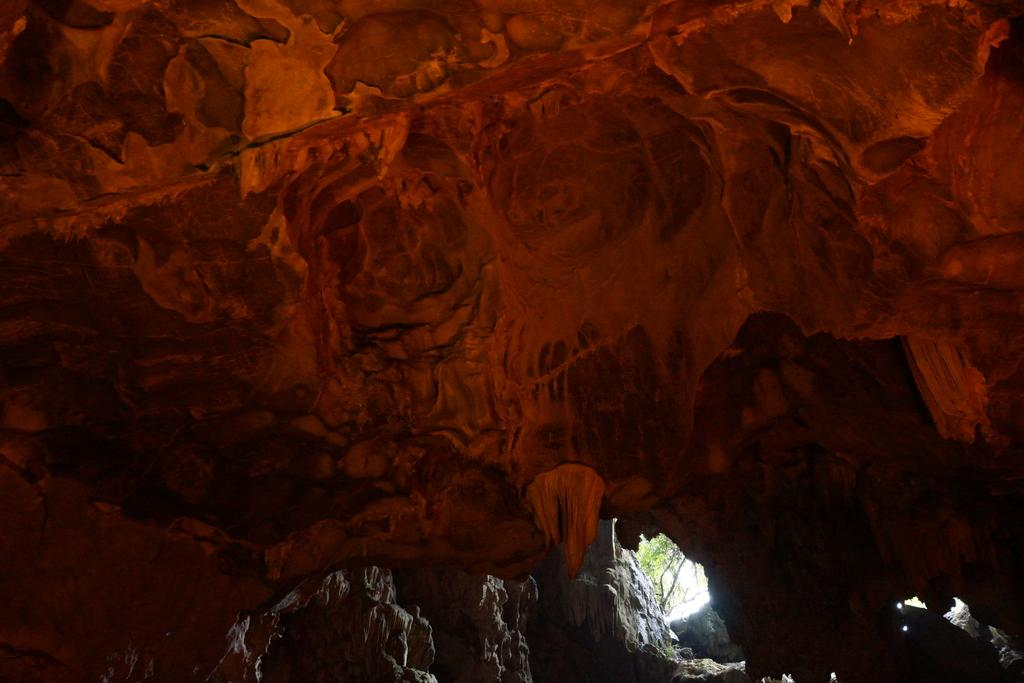What type of natural formation is present in the image? There is a cave in the image. What is the color of the cave? The cave is brown in color. What type of vegetation can be seen in the background of the image? There is a plant in the background of the image. What is the color of the plant? The plant is green in color. What type of appliance can be seen inside the cave in the image? There are no appliances present in the image; it features a cave and a plant in the background. How does the acoustics of the cave affect the sound in the image? The image does not provide any information about the acoustics of the cave or any sounds present. 